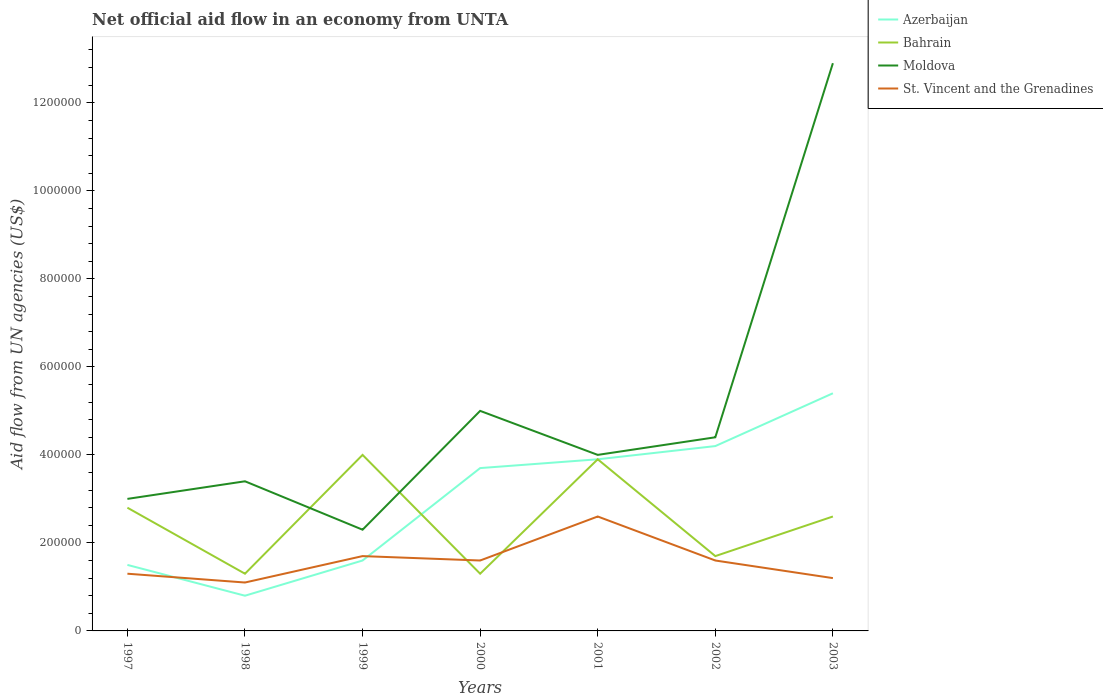How many different coloured lines are there?
Keep it short and to the point. 4. Is the number of lines equal to the number of legend labels?
Provide a short and direct response. Yes. What is the difference between the highest and the second highest net official aid flow in Bahrain?
Your response must be concise. 2.70e+05. What is the difference between the highest and the lowest net official aid flow in Azerbaijan?
Offer a terse response. 4. Is the net official aid flow in Moldova strictly greater than the net official aid flow in Azerbaijan over the years?
Ensure brevity in your answer.  No. How many lines are there?
Give a very brief answer. 4. How many years are there in the graph?
Provide a succinct answer. 7. Are the values on the major ticks of Y-axis written in scientific E-notation?
Offer a very short reply. No. Does the graph contain grids?
Make the answer very short. No. Where does the legend appear in the graph?
Your answer should be very brief. Top right. What is the title of the graph?
Give a very brief answer. Net official aid flow in an economy from UNTA. What is the label or title of the X-axis?
Make the answer very short. Years. What is the label or title of the Y-axis?
Provide a succinct answer. Aid flow from UN agencies (US$). What is the Aid flow from UN agencies (US$) in Azerbaijan in 1997?
Your answer should be very brief. 1.50e+05. What is the Aid flow from UN agencies (US$) in Moldova in 1997?
Your response must be concise. 3.00e+05. What is the Aid flow from UN agencies (US$) in Bahrain in 1998?
Make the answer very short. 1.30e+05. What is the Aid flow from UN agencies (US$) of Azerbaijan in 1999?
Make the answer very short. 1.60e+05. What is the Aid flow from UN agencies (US$) of Bahrain in 1999?
Make the answer very short. 4.00e+05. What is the Aid flow from UN agencies (US$) in St. Vincent and the Grenadines in 1999?
Offer a terse response. 1.70e+05. What is the Aid flow from UN agencies (US$) of Azerbaijan in 2000?
Offer a terse response. 3.70e+05. What is the Aid flow from UN agencies (US$) in St. Vincent and the Grenadines in 2000?
Provide a succinct answer. 1.60e+05. What is the Aid flow from UN agencies (US$) in Azerbaijan in 2001?
Ensure brevity in your answer.  3.90e+05. What is the Aid flow from UN agencies (US$) in Bahrain in 2001?
Offer a very short reply. 3.90e+05. What is the Aid flow from UN agencies (US$) in St. Vincent and the Grenadines in 2001?
Provide a short and direct response. 2.60e+05. What is the Aid flow from UN agencies (US$) of Bahrain in 2002?
Offer a terse response. 1.70e+05. What is the Aid flow from UN agencies (US$) of Moldova in 2002?
Your answer should be very brief. 4.40e+05. What is the Aid flow from UN agencies (US$) in Azerbaijan in 2003?
Provide a short and direct response. 5.40e+05. What is the Aid flow from UN agencies (US$) in Moldova in 2003?
Your answer should be very brief. 1.29e+06. What is the Aid flow from UN agencies (US$) in St. Vincent and the Grenadines in 2003?
Your response must be concise. 1.20e+05. Across all years, what is the maximum Aid flow from UN agencies (US$) of Azerbaijan?
Your answer should be very brief. 5.40e+05. Across all years, what is the maximum Aid flow from UN agencies (US$) of Bahrain?
Offer a terse response. 4.00e+05. Across all years, what is the maximum Aid flow from UN agencies (US$) of Moldova?
Your response must be concise. 1.29e+06. Across all years, what is the maximum Aid flow from UN agencies (US$) of St. Vincent and the Grenadines?
Your answer should be very brief. 2.60e+05. Across all years, what is the minimum Aid flow from UN agencies (US$) of St. Vincent and the Grenadines?
Keep it short and to the point. 1.10e+05. What is the total Aid flow from UN agencies (US$) in Azerbaijan in the graph?
Keep it short and to the point. 2.11e+06. What is the total Aid flow from UN agencies (US$) in Bahrain in the graph?
Keep it short and to the point. 1.76e+06. What is the total Aid flow from UN agencies (US$) in Moldova in the graph?
Offer a terse response. 3.50e+06. What is the total Aid flow from UN agencies (US$) in St. Vincent and the Grenadines in the graph?
Provide a succinct answer. 1.11e+06. What is the difference between the Aid flow from UN agencies (US$) in Bahrain in 1997 and that in 1998?
Provide a short and direct response. 1.50e+05. What is the difference between the Aid flow from UN agencies (US$) of Moldova in 1997 and that in 1999?
Your response must be concise. 7.00e+04. What is the difference between the Aid flow from UN agencies (US$) of Bahrain in 1997 and that in 2000?
Make the answer very short. 1.50e+05. What is the difference between the Aid flow from UN agencies (US$) of Moldova in 1997 and that in 2000?
Provide a succinct answer. -2.00e+05. What is the difference between the Aid flow from UN agencies (US$) in St. Vincent and the Grenadines in 1997 and that in 2000?
Offer a very short reply. -3.00e+04. What is the difference between the Aid flow from UN agencies (US$) in Bahrain in 1997 and that in 2001?
Ensure brevity in your answer.  -1.10e+05. What is the difference between the Aid flow from UN agencies (US$) in St. Vincent and the Grenadines in 1997 and that in 2001?
Make the answer very short. -1.30e+05. What is the difference between the Aid flow from UN agencies (US$) of Bahrain in 1997 and that in 2002?
Give a very brief answer. 1.10e+05. What is the difference between the Aid flow from UN agencies (US$) in Moldova in 1997 and that in 2002?
Your answer should be compact. -1.40e+05. What is the difference between the Aid flow from UN agencies (US$) of St. Vincent and the Grenadines in 1997 and that in 2002?
Give a very brief answer. -3.00e+04. What is the difference between the Aid flow from UN agencies (US$) in Azerbaijan in 1997 and that in 2003?
Give a very brief answer. -3.90e+05. What is the difference between the Aid flow from UN agencies (US$) in Bahrain in 1997 and that in 2003?
Provide a short and direct response. 2.00e+04. What is the difference between the Aid flow from UN agencies (US$) in Moldova in 1997 and that in 2003?
Your answer should be compact. -9.90e+05. What is the difference between the Aid flow from UN agencies (US$) in St. Vincent and the Grenadines in 1997 and that in 2003?
Give a very brief answer. 10000. What is the difference between the Aid flow from UN agencies (US$) of Azerbaijan in 1998 and that in 1999?
Your answer should be compact. -8.00e+04. What is the difference between the Aid flow from UN agencies (US$) in Bahrain in 1998 and that in 1999?
Offer a terse response. -2.70e+05. What is the difference between the Aid flow from UN agencies (US$) of Bahrain in 1998 and that in 2000?
Your answer should be compact. 0. What is the difference between the Aid flow from UN agencies (US$) of Moldova in 1998 and that in 2000?
Keep it short and to the point. -1.60e+05. What is the difference between the Aid flow from UN agencies (US$) in Azerbaijan in 1998 and that in 2001?
Provide a short and direct response. -3.10e+05. What is the difference between the Aid flow from UN agencies (US$) in Bahrain in 1998 and that in 2001?
Your response must be concise. -2.60e+05. What is the difference between the Aid flow from UN agencies (US$) in Moldova in 1998 and that in 2001?
Your response must be concise. -6.00e+04. What is the difference between the Aid flow from UN agencies (US$) in Bahrain in 1998 and that in 2002?
Offer a terse response. -4.00e+04. What is the difference between the Aid flow from UN agencies (US$) of Azerbaijan in 1998 and that in 2003?
Make the answer very short. -4.60e+05. What is the difference between the Aid flow from UN agencies (US$) in Bahrain in 1998 and that in 2003?
Provide a succinct answer. -1.30e+05. What is the difference between the Aid flow from UN agencies (US$) of Moldova in 1998 and that in 2003?
Provide a succinct answer. -9.50e+05. What is the difference between the Aid flow from UN agencies (US$) of St. Vincent and the Grenadines in 1998 and that in 2003?
Offer a very short reply. -10000. What is the difference between the Aid flow from UN agencies (US$) of Azerbaijan in 1999 and that in 2000?
Ensure brevity in your answer.  -2.10e+05. What is the difference between the Aid flow from UN agencies (US$) of St. Vincent and the Grenadines in 1999 and that in 2000?
Your answer should be very brief. 10000. What is the difference between the Aid flow from UN agencies (US$) of Azerbaijan in 1999 and that in 2001?
Your answer should be compact. -2.30e+05. What is the difference between the Aid flow from UN agencies (US$) in Moldova in 1999 and that in 2001?
Ensure brevity in your answer.  -1.70e+05. What is the difference between the Aid flow from UN agencies (US$) of Azerbaijan in 1999 and that in 2002?
Offer a terse response. -2.60e+05. What is the difference between the Aid flow from UN agencies (US$) in Bahrain in 1999 and that in 2002?
Provide a succinct answer. 2.30e+05. What is the difference between the Aid flow from UN agencies (US$) in Moldova in 1999 and that in 2002?
Give a very brief answer. -2.10e+05. What is the difference between the Aid flow from UN agencies (US$) of St. Vincent and the Grenadines in 1999 and that in 2002?
Provide a succinct answer. 10000. What is the difference between the Aid flow from UN agencies (US$) in Azerbaijan in 1999 and that in 2003?
Give a very brief answer. -3.80e+05. What is the difference between the Aid flow from UN agencies (US$) in Bahrain in 1999 and that in 2003?
Keep it short and to the point. 1.40e+05. What is the difference between the Aid flow from UN agencies (US$) of Moldova in 1999 and that in 2003?
Provide a succinct answer. -1.06e+06. What is the difference between the Aid flow from UN agencies (US$) of St. Vincent and the Grenadines in 1999 and that in 2003?
Make the answer very short. 5.00e+04. What is the difference between the Aid flow from UN agencies (US$) of Azerbaijan in 2000 and that in 2001?
Make the answer very short. -2.00e+04. What is the difference between the Aid flow from UN agencies (US$) in Bahrain in 2000 and that in 2001?
Ensure brevity in your answer.  -2.60e+05. What is the difference between the Aid flow from UN agencies (US$) of St. Vincent and the Grenadines in 2000 and that in 2001?
Provide a short and direct response. -1.00e+05. What is the difference between the Aid flow from UN agencies (US$) in Azerbaijan in 2000 and that in 2003?
Give a very brief answer. -1.70e+05. What is the difference between the Aid flow from UN agencies (US$) of Bahrain in 2000 and that in 2003?
Offer a terse response. -1.30e+05. What is the difference between the Aid flow from UN agencies (US$) of Moldova in 2000 and that in 2003?
Offer a very short reply. -7.90e+05. What is the difference between the Aid flow from UN agencies (US$) of Bahrain in 2001 and that in 2002?
Your answer should be very brief. 2.20e+05. What is the difference between the Aid flow from UN agencies (US$) in Moldova in 2001 and that in 2003?
Ensure brevity in your answer.  -8.90e+05. What is the difference between the Aid flow from UN agencies (US$) of Azerbaijan in 2002 and that in 2003?
Your response must be concise. -1.20e+05. What is the difference between the Aid flow from UN agencies (US$) of Moldova in 2002 and that in 2003?
Provide a succinct answer. -8.50e+05. What is the difference between the Aid flow from UN agencies (US$) of Azerbaijan in 1997 and the Aid flow from UN agencies (US$) of St. Vincent and the Grenadines in 1998?
Ensure brevity in your answer.  4.00e+04. What is the difference between the Aid flow from UN agencies (US$) of Bahrain in 1997 and the Aid flow from UN agencies (US$) of Moldova in 1998?
Keep it short and to the point. -6.00e+04. What is the difference between the Aid flow from UN agencies (US$) in Azerbaijan in 1997 and the Aid flow from UN agencies (US$) in Moldova in 1999?
Your answer should be very brief. -8.00e+04. What is the difference between the Aid flow from UN agencies (US$) in Bahrain in 1997 and the Aid flow from UN agencies (US$) in Moldova in 1999?
Your answer should be very brief. 5.00e+04. What is the difference between the Aid flow from UN agencies (US$) in Bahrain in 1997 and the Aid flow from UN agencies (US$) in St. Vincent and the Grenadines in 1999?
Your answer should be very brief. 1.10e+05. What is the difference between the Aid flow from UN agencies (US$) in Azerbaijan in 1997 and the Aid flow from UN agencies (US$) in Bahrain in 2000?
Your answer should be compact. 2.00e+04. What is the difference between the Aid flow from UN agencies (US$) in Azerbaijan in 1997 and the Aid flow from UN agencies (US$) in Moldova in 2000?
Make the answer very short. -3.50e+05. What is the difference between the Aid flow from UN agencies (US$) of Azerbaijan in 1997 and the Aid flow from UN agencies (US$) of Moldova in 2001?
Give a very brief answer. -2.50e+05. What is the difference between the Aid flow from UN agencies (US$) in Bahrain in 1997 and the Aid flow from UN agencies (US$) in St. Vincent and the Grenadines in 2001?
Your answer should be very brief. 2.00e+04. What is the difference between the Aid flow from UN agencies (US$) of Moldova in 1997 and the Aid flow from UN agencies (US$) of St. Vincent and the Grenadines in 2001?
Ensure brevity in your answer.  4.00e+04. What is the difference between the Aid flow from UN agencies (US$) in Azerbaijan in 1997 and the Aid flow from UN agencies (US$) in Bahrain in 2002?
Your response must be concise. -2.00e+04. What is the difference between the Aid flow from UN agencies (US$) of Azerbaijan in 1997 and the Aid flow from UN agencies (US$) of Moldova in 2002?
Ensure brevity in your answer.  -2.90e+05. What is the difference between the Aid flow from UN agencies (US$) of Bahrain in 1997 and the Aid flow from UN agencies (US$) of Moldova in 2002?
Make the answer very short. -1.60e+05. What is the difference between the Aid flow from UN agencies (US$) in Bahrain in 1997 and the Aid flow from UN agencies (US$) in St. Vincent and the Grenadines in 2002?
Your response must be concise. 1.20e+05. What is the difference between the Aid flow from UN agencies (US$) of Azerbaijan in 1997 and the Aid flow from UN agencies (US$) of Moldova in 2003?
Your answer should be very brief. -1.14e+06. What is the difference between the Aid flow from UN agencies (US$) of Bahrain in 1997 and the Aid flow from UN agencies (US$) of Moldova in 2003?
Keep it short and to the point. -1.01e+06. What is the difference between the Aid flow from UN agencies (US$) in Bahrain in 1997 and the Aid flow from UN agencies (US$) in St. Vincent and the Grenadines in 2003?
Your response must be concise. 1.60e+05. What is the difference between the Aid flow from UN agencies (US$) in Moldova in 1997 and the Aid flow from UN agencies (US$) in St. Vincent and the Grenadines in 2003?
Make the answer very short. 1.80e+05. What is the difference between the Aid flow from UN agencies (US$) of Azerbaijan in 1998 and the Aid flow from UN agencies (US$) of Bahrain in 1999?
Offer a terse response. -3.20e+05. What is the difference between the Aid flow from UN agencies (US$) in Azerbaijan in 1998 and the Aid flow from UN agencies (US$) in St. Vincent and the Grenadines in 1999?
Offer a very short reply. -9.00e+04. What is the difference between the Aid flow from UN agencies (US$) in Bahrain in 1998 and the Aid flow from UN agencies (US$) in Moldova in 1999?
Ensure brevity in your answer.  -1.00e+05. What is the difference between the Aid flow from UN agencies (US$) in Azerbaijan in 1998 and the Aid flow from UN agencies (US$) in Moldova in 2000?
Keep it short and to the point. -4.20e+05. What is the difference between the Aid flow from UN agencies (US$) of Bahrain in 1998 and the Aid flow from UN agencies (US$) of Moldova in 2000?
Offer a very short reply. -3.70e+05. What is the difference between the Aid flow from UN agencies (US$) of Bahrain in 1998 and the Aid flow from UN agencies (US$) of St. Vincent and the Grenadines in 2000?
Provide a short and direct response. -3.00e+04. What is the difference between the Aid flow from UN agencies (US$) in Azerbaijan in 1998 and the Aid flow from UN agencies (US$) in Bahrain in 2001?
Your answer should be compact. -3.10e+05. What is the difference between the Aid flow from UN agencies (US$) in Azerbaijan in 1998 and the Aid flow from UN agencies (US$) in Moldova in 2001?
Your answer should be compact. -3.20e+05. What is the difference between the Aid flow from UN agencies (US$) of Bahrain in 1998 and the Aid flow from UN agencies (US$) of St. Vincent and the Grenadines in 2001?
Offer a very short reply. -1.30e+05. What is the difference between the Aid flow from UN agencies (US$) of Azerbaijan in 1998 and the Aid flow from UN agencies (US$) of Bahrain in 2002?
Provide a succinct answer. -9.00e+04. What is the difference between the Aid flow from UN agencies (US$) of Azerbaijan in 1998 and the Aid flow from UN agencies (US$) of Moldova in 2002?
Ensure brevity in your answer.  -3.60e+05. What is the difference between the Aid flow from UN agencies (US$) in Bahrain in 1998 and the Aid flow from UN agencies (US$) in Moldova in 2002?
Keep it short and to the point. -3.10e+05. What is the difference between the Aid flow from UN agencies (US$) in Moldova in 1998 and the Aid flow from UN agencies (US$) in St. Vincent and the Grenadines in 2002?
Offer a very short reply. 1.80e+05. What is the difference between the Aid flow from UN agencies (US$) of Azerbaijan in 1998 and the Aid flow from UN agencies (US$) of Moldova in 2003?
Make the answer very short. -1.21e+06. What is the difference between the Aid flow from UN agencies (US$) in Azerbaijan in 1998 and the Aid flow from UN agencies (US$) in St. Vincent and the Grenadines in 2003?
Provide a succinct answer. -4.00e+04. What is the difference between the Aid flow from UN agencies (US$) of Bahrain in 1998 and the Aid flow from UN agencies (US$) of Moldova in 2003?
Ensure brevity in your answer.  -1.16e+06. What is the difference between the Aid flow from UN agencies (US$) of Moldova in 1998 and the Aid flow from UN agencies (US$) of St. Vincent and the Grenadines in 2003?
Make the answer very short. 2.20e+05. What is the difference between the Aid flow from UN agencies (US$) of Azerbaijan in 1999 and the Aid flow from UN agencies (US$) of Bahrain in 2000?
Offer a very short reply. 3.00e+04. What is the difference between the Aid flow from UN agencies (US$) in Azerbaijan in 1999 and the Aid flow from UN agencies (US$) in Moldova in 2000?
Your answer should be compact. -3.40e+05. What is the difference between the Aid flow from UN agencies (US$) of Azerbaijan in 1999 and the Aid flow from UN agencies (US$) of Bahrain in 2002?
Make the answer very short. -10000. What is the difference between the Aid flow from UN agencies (US$) in Azerbaijan in 1999 and the Aid flow from UN agencies (US$) in Moldova in 2002?
Provide a succinct answer. -2.80e+05. What is the difference between the Aid flow from UN agencies (US$) in Azerbaijan in 1999 and the Aid flow from UN agencies (US$) in St. Vincent and the Grenadines in 2002?
Give a very brief answer. 0. What is the difference between the Aid flow from UN agencies (US$) of Bahrain in 1999 and the Aid flow from UN agencies (US$) of Moldova in 2002?
Ensure brevity in your answer.  -4.00e+04. What is the difference between the Aid flow from UN agencies (US$) of Moldova in 1999 and the Aid flow from UN agencies (US$) of St. Vincent and the Grenadines in 2002?
Your answer should be compact. 7.00e+04. What is the difference between the Aid flow from UN agencies (US$) in Azerbaijan in 1999 and the Aid flow from UN agencies (US$) in Moldova in 2003?
Provide a succinct answer. -1.13e+06. What is the difference between the Aid flow from UN agencies (US$) in Bahrain in 1999 and the Aid flow from UN agencies (US$) in Moldova in 2003?
Provide a succinct answer. -8.90e+05. What is the difference between the Aid flow from UN agencies (US$) of Bahrain in 1999 and the Aid flow from UN agencies (US$) of St. Vincent and the Grenadines in 2003?
Offer a very short reply. 2.80e+05. What is the difference between the Aid flow from UN agencies (US$) in Azerbaijan in 2000 and the Aid flow from UN agencies (US$) in Bahrain in 2001?
Your response must be concise. -2.00e+04. What is the difference between the Aid flow from UN agencies (US$) of Azerbaijan in 2000 and the Aid flow from UN agencies (US$) of St. Vincent and the Grenadines in 2001?
Your response must be concise. 1.10e+05. What is the difference between the Aid flow from UN agencies (US$) of Bahrain in 2000 and the Aid flow from UN agencies (US$) of Moldova in 2001?
Your answer should be compact. -2.70e+05. What is the difference between the Aid flow from UN agencies (US$) in Bahrain in 2000 and the Aid flow from UN agencies (US$) in St. Vincent and the Grenadines in 2001?
Offer a very short reply. -1.30e+05. What is the difference between the Aid flow from UN agencies (US$) in Moldova in 2000 and the Aid flow from UN agencies (US$) in St. Vincent and the Grenadines in 2001?
Provide a succinct answer. 2.40e+05. What is the difference between the Aid flow from UN agencies (US$) in Azerbaijan in 2000 and the Aid flow from UN agencies (US$) in Bahrain in 2002?
Give a very brief answer. 2.00e+05. What is the difference between the Aid flow from UN agencies (US$) of Bahrain in 2000 and the Aid flow from UN agencies (US$) of Moldova in 2002?
Keep it short and to the point. -3.10e+05. What is the difference between the Aid flow from UN agencies (US$) of Moldova in 2000 and the Aid flow from UN agencies (US$) of St. Vincent and the Grenadines in 2002?
Offer a terse response. 3.40e+05. What is the difference between the Aid flow from UN agencies (US$) in Azerbaijan in 2000 and the Aid flow from UN agencies (US$) in Moldova in 2003?
Your answer should be very brief. -9.20e+05. What is the difference between the Aid flow from UN agencies (US$) of Azerbaijan in 2000 and the Aid flow from UN agencies (US$) of St. Vincent and the Grenadines in 2003?
Your response must be concise. 2.50e+05. What is the difference between the Aid flow from UN agencies (US$) of Bahrain in 2000 and the Aid flow from UN agencies (US$) of Moldova in 2003?
Provide a succinct answer. -1.16e+06. What is the difference between the Aid flow from UN agencies (US$) in Azerbaijan in 2001 and the Aid flow from UN agencies (US$) in Moldova in 2002?
Make the answer very short. -5.00e+04. What is the difference between the Aid flow from UN agencies (US$) in Bahrain in 2001 and the Aid flow from UN agencies (US$) in Moldova in 2002?
Offer a very short reply. -5.00e+04. What is the difference between the Aid flow from UN agencies (US$) in Bahrain in 2001 and the Aid flow from UN agencies (US$) in St. Vincent and the Grenadines in 2002?
Give a very brief answer. 2.30e+05. What is the difference between the Aid flow from UN agencies (US$) in Azerbaijan in 2001 and the Aid flow from UN agencies (US$) in Bahrain in 2003?
Keep it short and to the point. 1.30e+05. What is the difference between the Aid flow from UN agencies (US$) of Azerbaijan in 2001 and the Aid flow from UN agencies (US$) of Moldova in 2003?
Your response must be concise. -9.00e+05. What is the difference between the Aid flow from UN agencies (US$) in Bahrain in 2001 and the Aid flow from UN agencies (US$) in Moldova in 2003?
Your answer should be very brief. -9.00e+05. What is the difference between the Aid flow from UN agencies (US$) in Bahrain in 2001 and the Aid flow from UN agencies (US$) in St. Vincent and the Grenadines in 2003?
Ensure brevity in your answer.  2.70e+05. What is the difference between the Aid flow from UN agencies (US$) of Moldova in 2001 and the Aid flow from UN agencies (US$) of St. Vincent and the Grenadines in 2003?
Your response must be concise. 2.80e+05. What is the difference between the Aid flow from UN agencies (US$) in Azerbaijan in 2002 and the Aid flow from UN agencies (US$) in Bahrain in 2003?
Your response must be concise. 1.60e+05. What is the difference between the Aid flow from UN agencies (US$) of Azerbaijan in 2002 and the Aid flow from UN agencies (US$) of Moldova in 2003?
Ensure brevity in your answer.  -8.70e+05. What is the difference between the Aid flow from UN agencies (US$) of Bahrain in 2002 and the Aid flow from UN agencies (US$) of Moldova in 2003?
Offer a very short reply. -1.12e+06. What is the difference between the Aid flow from UN agencies (US$) in Moldova in 2002 and the Aid flow from UN agencies (US$) in St. Vincent and the Grenadines in 2003?
Offer a terse response. 3.20e+05. What is the average Aid flow from UN agencies (US$) in Azerbaijan per year?
Make the answer very short. 3.01e+05. What is the average Aid flow from UN agencies (US$) in Bahrain per year?
Provide a succinct answer. 2.51e+05. What is the average Aid flow from UN agencies (US$) of Moldova per year?
Offer a very short reply. 5.00e+05. What is the average Aid flow from UN agencies (US$) in St. Vincent and the Grenadines per year?
Keep it short and to the point. 1.59e+05. In the year 1997, what is the difference between the Aid flow from UN agencies (US$) of Azerbaijan and Aid flow from UN agencies (US$) of Moldova?
Your response must be concise. -1.50e+05. In the year 1997, what is the difference between the Aid flow from UN agencies (US$) of Azerbaijan and Aid flow from UN agencies (US$) of St. Vincent and the Grenadines?
Your response must be concise. 2.00e+04. In the year 1997, what is the difference between the Aid flow from UN agencies (US$) of Bahrain and Aid flow from UN agencies (US$) of Moldova?
Offer a terse response. -2.00e+04. In the year 1997, what is the difference between the Aid flow from UN agencies (US$) of Bahrain and Aid flow from UN agencies (US$) of St. Vincent and the Grenadines?
Offer a terse response. 1.50e+05. In the year 1997, what is the difference between the Aid flow from UN agencies (US$) in Moldova and Aid flow from UN agencies (US$) in St. Vincent and the Grenadines?
Your response must be concise. 1.70e+05. In the year 1998, what is the difference between the Aid flow from UN agencies (US$) in Azerbaijan and Aid flow from UN agencies (US$) in Bahrain?
Provide a succinct answer. -5.00e+04. In the year 1998, what is the difference between the Aid flow from UN agencies (US$) of Azerbaijan and Aid flow from UN agencies (US$) of St. Vincent and the Grenadines?
Ensure brevity in your answer.  -3.00e+04. In the year 1998, what is the difference between the Aid flow from UN agencies (US$) of Bahrain and Aid flow from UN agencies (US$) of St. Vincent and the Grenadines?
Your answer should be compact. 2.00e+04. In the year 1998, what is the difference between the Aid flow from UN agencies (US$) in Moldova and Aid flow from UN agencies (US$) in St. Vincent and the Grenadines?
Keep it short and to the point. 2.30e+05. In the year 1999, what is the difference between the Aid flow from UN agencies (US$) in Azerbaijan and Aid flow from UN agencies (US$) in Bahrain?
Your response must be concise. -2.40e+05. In the year 1999, what is the difference between the Aid flow from UN agencies (US$) of Azerbaijan and Aid flow from UN agencies (US$) of Moldova?
Make the answer very short. -7.00e+04. In the year 1999, what is the difference between the Aid flow from UN agencies (US$) of Moldova and Aid flow from UN agencies (US$) of St. Vincent and the Grenadines?
Give a very brief answer. 6.00e+04. In the year 2000, what is the difference between the Aid flow from UN agencies (US$) of Azerbaijan and Aid flow from UN agencies (US$) of St. Vincent and the Grenadines?
Give a very brief answer. 2.10e+05. In the year 2000, what is the difference between the Aid flow from UN agencies (US$) in Bahrain and Aid flow from UN agencies (US$) in Moldova?
Make the answer very short. -3.70e+05. In the year 2002, what is the difference between the Aid flow from UN agencies (US$) of Azerbaijan and Aid flow from UN agencies (US$) of St. Vincent and the Grenadines?
Provide a succinct answer. 2.60e+05. In the year 2003, what is the difference between the Aid flow from UN agencies (US$) in Azerbaijan and Aid flow from UN agencies (US$) in Bahrain?
Make the answer very short. 2.80e+05. In the year 2003, what is the difference between the Aid flow from UN agencies (US$) in Azerbaijan and Aid flow from UN agencies (US$) in Moldova?
Offer a very short reply. -7.50e+05. In the year 2003, what is the difference between the Aid flow from UN agencies (US$) of Azerbaijan and Aid flow from UN agencies (US$) of St. Vincent and the Grenadines?
Your response must be concise. 4.20e+05. In the year 2003, what is the difference between the Aid flow from UN agencies (US$) of Bahrain and Aid flow from UN agencies (US$) of Moldova?
Provide a succinct answer. -1.03e+06. In the year 2003, what is the difference between the Aid flow from UN agencies (US$) in Moldova and Aid flow from UN agencies (US$) in St. Vincent and the Grenadines?
Give a very brief answer. 1.17e+06. What is the ratio of the Aid flow from UN agencies (US$) of Azerbaijan in 1997 to that in 1998?
Give a very brief answer. 1.88. What is the ratio of the Aid flow from UN agencies (US$) of Bahrain in 1997 to that in 1998?
Offer a very short reply. 2.15. What is the ratio of the Aid flow from UN agencies (US$) in Moldova in 1997 to that in 1998?
Your answer should be compact. 0.88. What is the ratio of the Aid flow from UN agencies (US$) of St. Vincent and the Grenadines in 1997 to that in 1998?
Make the answer very short. 1.18. What is the ratio of the Aid flow from UN agencies (US$) of Azerbaijan in 1997 to that in 1999?
Ensure brevity in your answer.  0.94. What is the ratio of the Aid flow from UN agencies (US$) in Bahrain in 1997 to that in 1999?
Keep it short and to the point. 0.7. What is the ratio of the Aid flow from UN agencies (US$) of Moldova in 1997 to that in 1999?
Offer a terse response. 1.3. What is the ratio of the Aid flow from UN agencies (US$) in St. Vincent and the Grenadines in 1997 to that in 1999?
Keep it short and to the point. 0.76. What is the ratio of the Aid flow from UN agencies (US$) of Azerbaijan in 1997 to that in 2000?
Make the answer very short. 0.41. What is the ratio of the Aid flow from UN agencies (US$) in Bahrain in 1997 to that in 2000?
Your answer should be very brief. 2.15. What is the ratio of the Aid flow from UN agencies (US$) in Moldova in 1997 to that in 2000?
Make the answer very short. 0.6. What is the ratio of the Aid flow from UN agencies (US$) in St. Vincent and the Grenadines in 1997 to that in 2000?
Provide a short and direct response. 0.81. What is the ratio of the Aid flow from UN agencies (US$) in Azerbaijan in 1997 to that in 2001?
Your response must be concise. 0.38. What is the ratio of the Aid flow from UN agencies (US$) in Bahrain in 1997 to that in 2001?
Offer a terse response. 0.72. What is the ratio of the Aid flow from UN agencies (US$) in Moldova in 1997 to that in 2001?
Make the answer very short. 0.75. What is the ratio of the Aid flow from UN agencies (US$) of Azerbaijan in 1997 to that in 2002?
Your response must be concise. 0.36. What is the ratio of the Aid flow from UN agencies (US$) in Bahrain in 1997 to that in 2002?
Offer a very short reply. 1.65. What is the ratio of the Aid flow from UN agencies (US$) of Moldova in 1997 to that in 2002?
Provide a short and direct response. 0.68. What is the ratio of the Aid flow from UN agencies (US$) of St. Vincent and the Grenadines in 1997 to that in 2002?
Give a very brief answer. 0.81. What is the ratio of the Aid flow from UN agencies (US$) of Azerbaijan in 1997 to that in 2003?
Give a very brief answer. 0.28. What is the ratio of the Aid flow from UN agencies (US$) of Bahrain in 1997 to that in 2003?
Give a very brief answer. 1.08. What is the ratio of the Aid flow from UN agencies (US$) in Moldova in 1997 to that in 2003?
Make the answer very short. 0.23. What is the ratio of the Aid flow from UN agencies (US$) of Bahrain in 1998 to that in 1999?
Ensure brevity in your answer.  0.33. What is the ratio of the Aid flow from UN agencies (US$) in Moldova in 1998 to that in 1999?
Offer a terse response. 1.48. What is the ratio of the Aid flow from UN agencies (US$) of St. Vincent and the Grenadines in 1998 to that in 1999?
Make the answer very short. 0.65. What is the ratio of the Aid flow from UN agencies (US$) of Azerbaijan in 1998 to that in 2000?
Offer a very short reply. 0.22. What is the ratio of the Aid flow from UN agencies (US$) in Bahrain in 1998 to that in 2000?
Provide a succinct answer. 1. What is the ratio of the Aid flow from UN agencies (US$) of Moldova in 1998 to that in 2000?
Offer a terse response. 0.68. What is the ratio of the Aid flow from UN agencies (US$) of St. Vincent and the Grenadines in 1998 to that in 2000?
Provide a succinct answer. 0.69. What is the ratio of the Aid flow from UN agencies (US$) of Azerbaijan in 1998 to that in 2001?
Your answer should be compact. 0.21. What is the ratio of the Aid flow from UN agencies (US$) in Bahrain in 1998 to that in 2001?
Make the answer very short. 0.33. What is the ratio of the Aid flow from UN agencies (US$) of St. Vincent and the Grenadines in 1998 to that in 2001?
Your answer should be compact. 0.42. What is the ratio of the Aid flow from UN agencies (US$) in Azerbaijan in 1998 to that in 2002?
Your response must be concise. 0.19. What is the ratio of the Aid flow from UN agencies (US$) of Bahrain in 1998 to that in 2002?
Make the answer very short. 0.76. What is the ratio of the Aid flow from UN agencies (US$) in Moldova in 1998 to that in 2002?
Make the answer very short. 0.77. What is the ratio of the Aid flow from UN agencies (US$) of St. Vincent and the Grenadines in 1998 to that in 2002?
Your answer should be very brief. 0.69. What is the ratio of the Aid flow from UN agencies (US$) in Azerbaijan in 1998 to that in 2003?
Offer a very short reply. 0.15. What is the ratio of the Aid flow from UN agencies (US$) of Moldova in 1998 to that in 2003?
Provide a short and direct response. 0.26. What is the ratio of the Aid flow from UN agencies (US$) in St. Vincent and the Grenadines in 1998 to that in 2003?
Your answer should be very brief. 0.92. What is the ratio of the Aid flow from UN agencies (US$) in Azerbaijan in 1999 to that in 2000?
Provide a short and direct response. 0.43. What is the ratio of the Aid flow from UN agencies (US$) of Bahrain in 1999 to that in 2000?
Ensure brevity in your answer.  3.08. What is the ratio of the Aid flow from UN agencies (US$) of Moldova in 1999 to that in 2000?
Make the answer very short. 0.46. What is the ratio of the Aid flow from UN agencies (US$) of Azerbaijan in 1999 to that in 2001?
Provide a succinct answer. 0.41. What is the ratio of the Aid flow from UN agencies (US$) in Bahrain in 1999 to that in 2001?
Provide a succinct answer. 1.03. What is the ratio of the Aid flow from UN agencies (US$) of Moldova in 1999 to that in 2001?
Offer a terse response. 0.57. What is the ratio of the Aid flow from UN agencies (US$) in St. Vincent and the Grenadines in 1999 to that in 2001?
Provide a short and direct response. 0.65. What is the ratio of the Aid flow from UN agencies (US$) in Azerbaijan in 1999 to that in 2002?
Offer a terse response. 0.38. What is the ratio of the Aid flow from UN agencies (US$) of Bahrain in 1999 to that in 2002?
Keep it short and to the point. 2.35. What is the ratio of the Aid flow from UN agencies (US$) of Moldova in 1999 to that in 2002?
Ensure brevity in your answer.  0.52. What is the ratio of the Aid flow from UN agencies (US$) of St. Vincent and the Grenadines in 1999 to that in 2002?
Your response must be concise. 1.06. What is the ratio of the Aid flow from UN agencies (US$) of Azerbaijan in 1999 to that in 2003?
Provide a short and direct response. 0.3. What is the ratio of the Aid flow from UN agencies (US$) in Bahrain in 1999 to that in 2003?
Offer a very short reply. 1.54. What is the ratio of the Aid flow from UN agencies (US$) in Moldova in 1999 to that in 2003?
Offer a very short reply. 0.18. What is the ratio of the Aid flow from UN agencies (US$) of St. Vincent and the Grenadines in 1999 to that in 2003?
Offer a very short reply. 1.42. What is the ratio of the Aid flow from UN agencies (US$) of Azerbaijan in 2000 to that in 2001?
Make the answer very short. 0.95. What is the ratio of the Aid flow from UN agencies (US$) of Bahrain in 2000 to that in 2001?
Ensure brevity in your answer.  0.33. What is the ratio of the Aid flow from UN agencies (US$) in St. Vincent and the Grenadines in 2000 to that in 2001?
Keep it short and to the point. 0.62. What is the ratio of the Aid flow from UN agencies (US$) in Azerbaijan in 2000 to that in 2002?
Give a very brief answer. 0.88. What is the ratio of the Aid flow from UN agencies (US$) of Bahrain in 2000 to that in 2002?
Your answer should be very brief. 0.76. What is the ratio of the Aid flow from UN agencies (US$) in Moldova in 2000 to that in 2002?
Ensure brevity in your answer.  1.14. What is the ratio of the Aid flow from UN agencies (US$) of St. Vincent and the Grenadines in 2000 to that in 2002?
Your answer should be compact. 1. What is the ratio of the Aid flow from UN agencies (US$) of Azerbaijan in 2000 to that in 2003?
Offer a terse response. 0.69. What is the ratio of the Aid flow from UN agencies (US$) of Bahrain in 2000 to that in 2003?
Keep it short and to the point. 0.5. What is the ratio of the Aid flow from UN agencies (US$) of Moldova in 2000 to that in 2003?
Your answer should be very brief. 0.39. What is the ratio of the Aid flow from UN agencies (US$) in St. Vincent and the Grenadines in 2000 to that in 2003?
Your answer should be very brief. 1.33. What is the ratio of the Aid flow from UN agencies (US$) of Bahrain in 2001 to that in 2002?
Your answer should be very brief. 2.29. What is the ratio of the Aid flow from UN agencies (US$) in St. Vincent and the Grenadines in 2001 to that in 2002?
Provide a succinct answer. 1.62. What is the ratio of the Aid flow from UN agencies (US$) in Azerbaijan in 2001 to that in 2003?
Your answer should be very brief. 0.72. What is the ratio of the Aid flow from UN agencies (US$) of Moldova in 2001 to that in 2003?
Provide a succinct answer. 0.31. What is the ratio of the Aid flow from UN agencies (US$) of St. Vincent and the Grenadines in 2001 to that in 2003?
Give a very brief answer. 2.17. What is the ratio of the Aid flow from UN agencies (US$) in Bahrain in 2002 to that in 2003?
Give a very brief answer. 0.65. What is the ratio of the Aid flow from UN agencies (US$) in Moldova in 2002 to that in 2003?
Ensure brevity in your answer.  0.34. What is the ratio of the Aid flow from UN agencies (US$) of St. Vincent and the Grenadines in 2002 to that in 2003?
Provide a succinct answer. 1.33. What is the difference between the highest and the second highest Aid flow from UN agencies (US$) of Moldova?
Your answer should be compact. 7.90e+05. What is the difference between the highest and the lowest Aid flow from UN agencies (US$) in Moldova?
Make the answer very short. 1.06e+06. What is the difference between the highest and the lowest Aid flow from UN agencies (US$) of St. Vincent and the Grenadines?
Ensure brevity in your answer.  1.50e+05. 